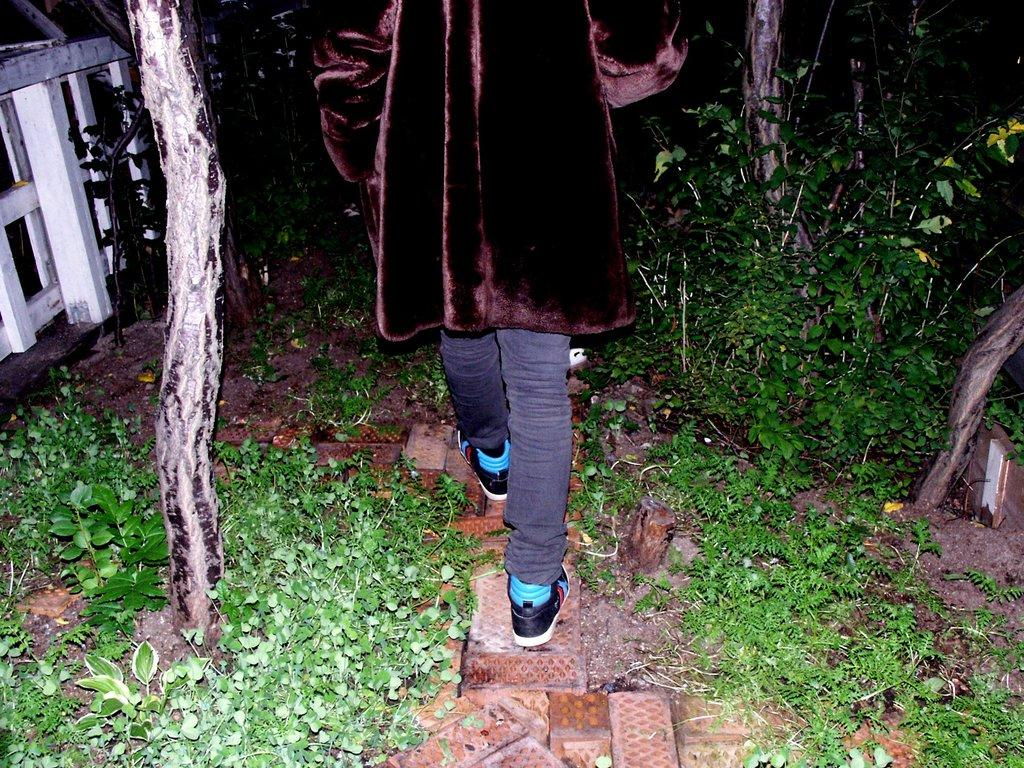What is the person in the image doing? There is a person walking in the image. What is the person wearing? The person is wearing a brown jacket. What can be seen at the bottom of the image? There are small plants at the bottom of the image. What is on the right side of the image? There are trees on the right side of the image. What is on the left side of the image? There is a fencing on the left side of the image. How much money is the person carrying in the image? There is no indication of money in the image, so it cannot be determined how much the person is carrying. 